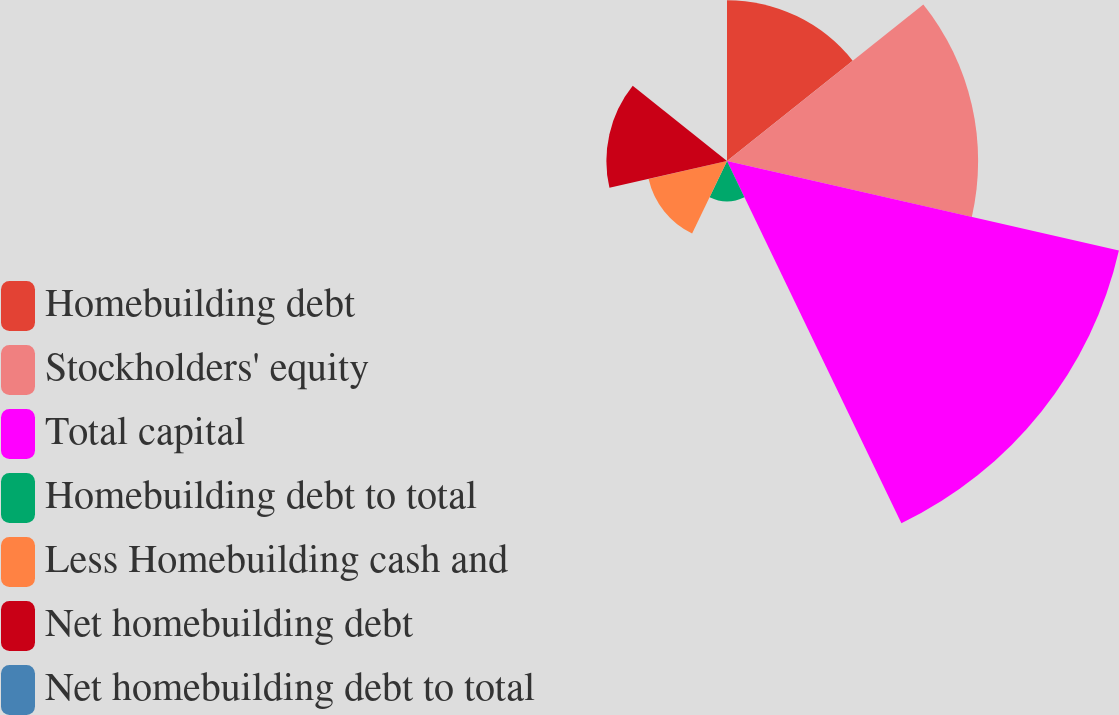Convert chart. <chart><loc_0><loc_0><loc_500><loc_500><pie_chart><fcel>Homebuilding debt<fcel>Stockholders' equity<fcel>Total capital<fcel>Homebuilding debt to total<fcel>Less Homebuilding cash and<fcel>Net homebuilding debt<fcel>Net homebuilding debt to total<nl><fcel>15.24%<fcel>23.8%<fcel>38.1%<fcel>3.81%<fcel>7.62%<fcel>11.43%<fcel>0.0%<nl></chart> 